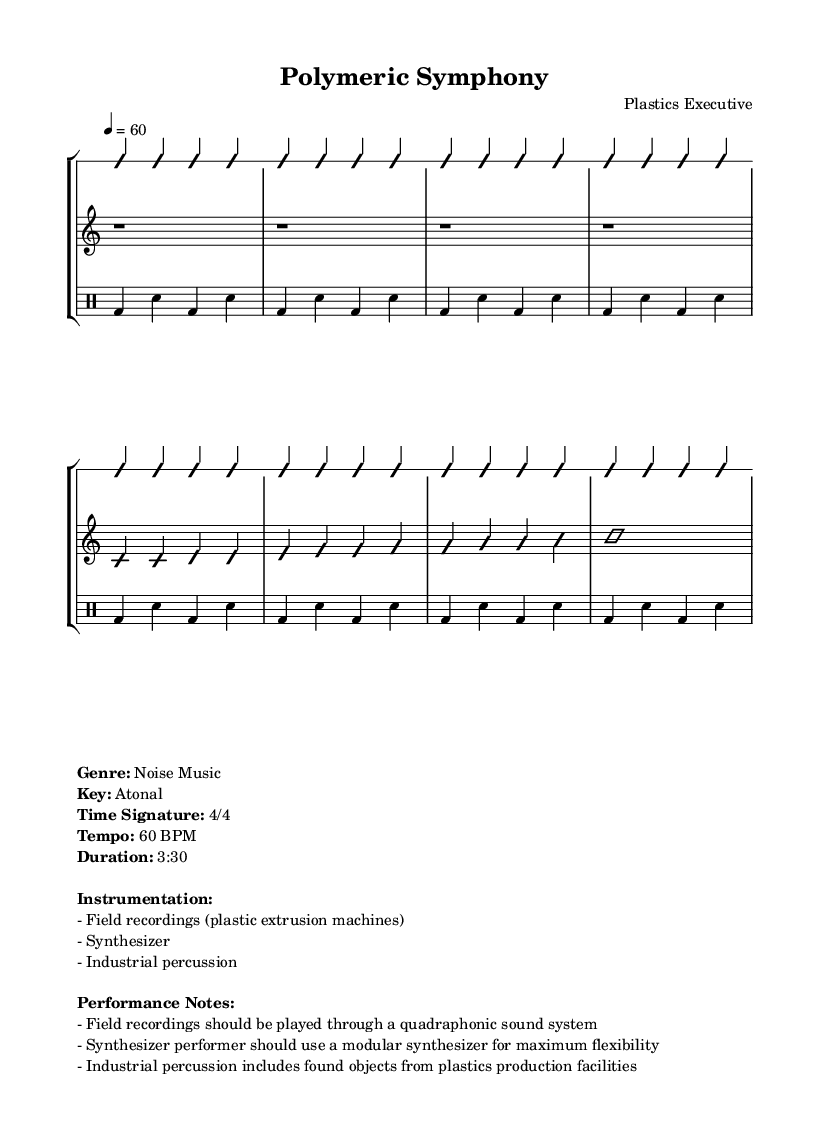What is the genre of this music? The genre is explicitly stated in the markup section as "Noise Music."
Answer: Noise Music What is the time signature of this music? The time signature is indicated at the beginning of the piece, showing consistent patterns of 4/4.
Answer: 4/4 What is the tempo marking of this music? The tempo is provided in the markup with a BPM (beats per minute) of 60.
Answer: 60 BPM What instruments are used in this composition? The instrumentation is listed in the markup: Field recordings, Synthesizer, Industrial percussion.
Answer: Field recordings, Synthesizer, Industrial percussion What type of sound system should the field recordings be played through? The performance notes specify that the field recordings should be played through a "quadraphonic sound system."
Answer: Quadraphonic sound system How does the synthesizer performer achieve maximum flexibility? The performance notes suggest using a "modular synthesizer" for maximum flexibility.
Answer: Modular synthesizer What is the duration of this musical piece? The duration is explicitly stated in the markup section as "3:30."
Answer: 3:30 